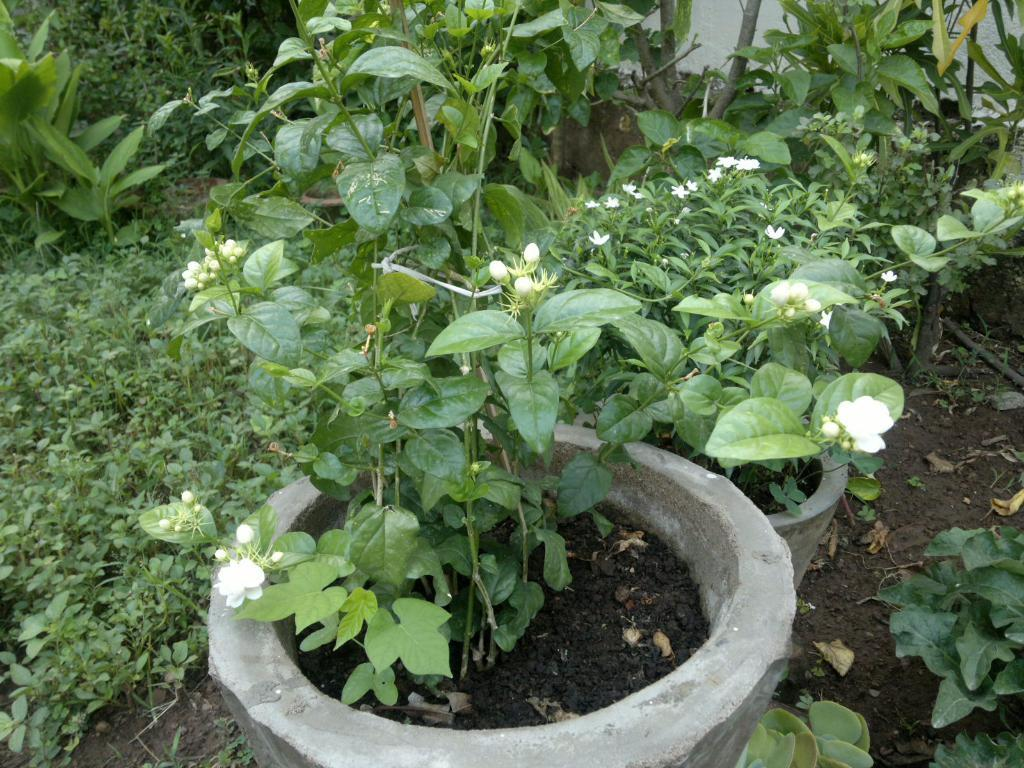What is the main subject in the center of the image? There are plant pots in the center of the image. Can you describe the surrounding area in the image? There is greenery around the area of the image. What type of impulse can be seen affecting the plant pots in the image? There is no impulse affecting the plant pots in the image; they are stationary. Is there an island visible in the image? There is no island present in the image. 